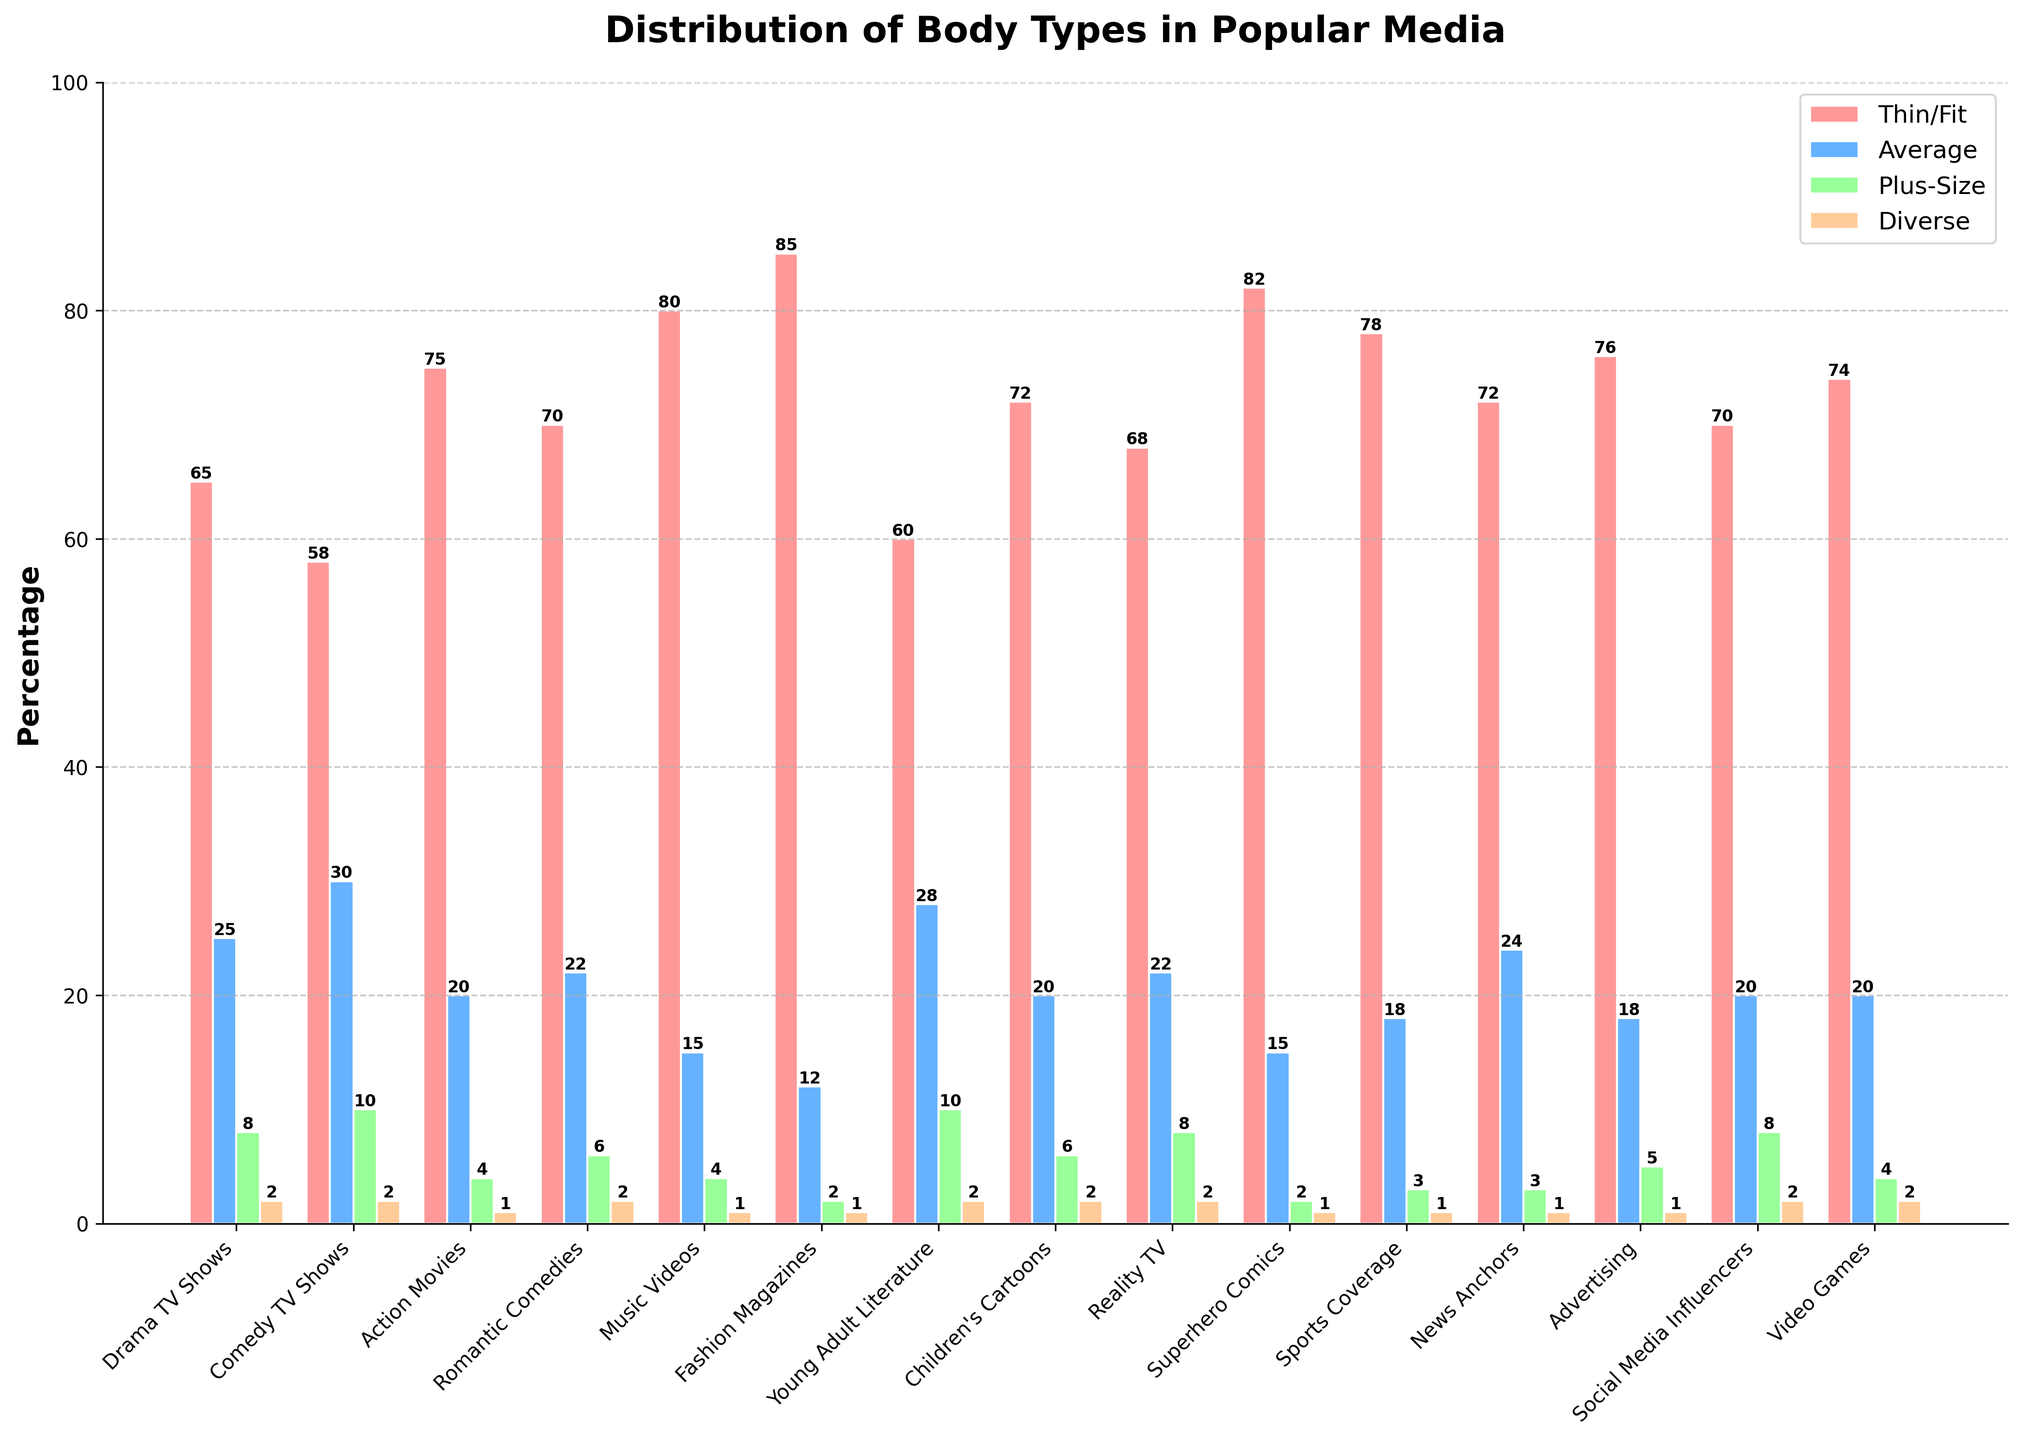Which genre has the highest percentage of Thin/Fit body types represented? By visually identifying the tallest bar in the 'Thin/Fit' series, we see that Fashion Magazines have the highest.
Answer: Fashion Magazines What is the percentage difference of Average body types between Comedy TV Shows and Video Games? Comedy TV Shows have 30% and Video Games have 20%, so the difference is 30 - 20 = 10%.
Answer: 10% Among Romantic Comedies and Advertising, which genre has a higher percentage of Plus-Size body types represented and by how much? Romantic Comedies have 6% while Advertising has 5% for Plus-Size, so Romantic Comedies have 1% more.
Answer: Romantic Comedies, 1% What's the total percentage of Thin/Fit and Average body types represented in Action Movies? The percentages of Thin/Fit and Average in Action Movies are 75% and 20% respectively. Their total is 75 + 20 = 95%.
Answer: 95% How does the representation of Diverse body types compare between Children's Cartoons and Social Media Influencers? Both Children's Cartoons and Social Media Influencers have the same percentage of Diverse body types, which is 2%.
Answer: Equal What is the average percentage of Plus-Size body types across all genres? Summing up the Plus-Size percentages: 8+10+4+6+4+2+10+6+8+2+3+3+5+8+4 = 75, and there are 15 genres. Therefore, the average is 75/15 = 5%.
Answer: 5% Which genre has a more balanced representation of body types and why? Young Adult Literature and Comedy TV Shows have the most balanced representation, as their percentages across different body types are more evenly distributed compared to others. For Young Adult Literature: Thin/Fit 60%, Average 28%, Plus-Size 10%, Diverse 2%. For Comedy TV Shows: Thin/Fit 58%, Average 30%, Plus-Size 10%, Diverse 2%.
Answer: Young Adult Literature, Comedy TV Shows How many genres have more than 70% representation in Thin/Fit body types? By checking the Thin/Fit bars, Fashion Magazines (85%), Superhero Comics (82%), Music Videos (80%), Sports Coverage (78%), Action Movies (75%), Romantic Comedies (70%), and Video Games (74%) all have over 70%. This totals 7 genres.
Answer: 7 